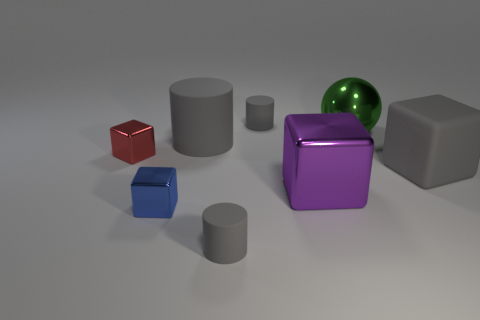Subtract all small gray matte cylinders. How many cylinders are left? 1 Subtract 2 cylinders. How many cylinders are left? 1 Subtract all purple cubes. How many cubes are left? 3 Add 2 tiny rubber cylinders. How many objects exist? 10 Subtract all cylinders. How many objects are left? 5 Subtract all brown cylinders. How many gray blocks are left? 1 Subtract all tiny blue metallic objects. Subtract all big spheres. How many objects are left? 6 Add 4 tiny cylinders. How many tiny cylinders are left? 6 Add 5 tiny blue rubber spheres. How many tiny blue rubber spheres exist? 5 Subtract 0 brown cylinders. How many objects are left? 8 